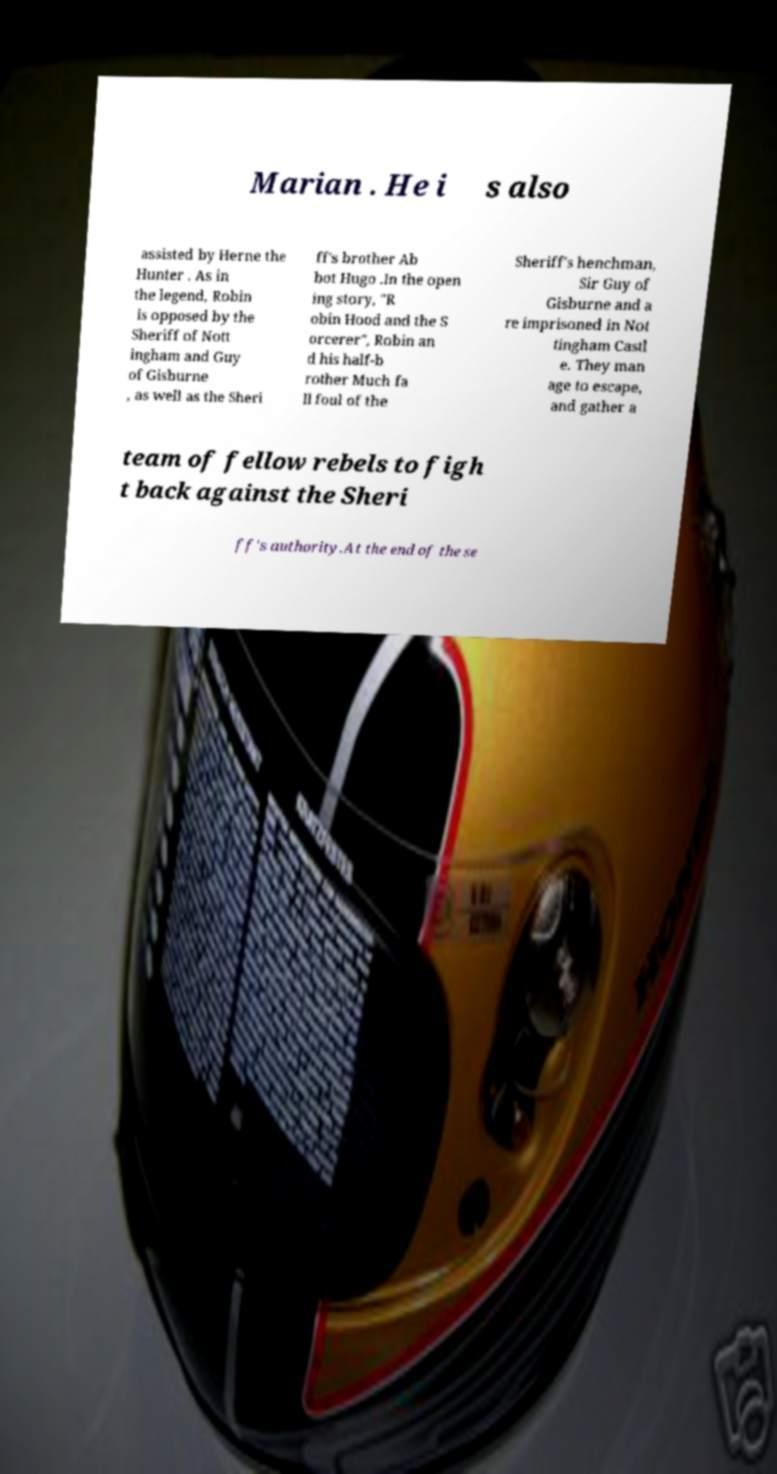Please identify and transcribe the text found in this image. Marian . He i s also assisted by Herne the Hunter . As in the legend, Robin is opposed by the Sheriff of Nott ingham and Guy of Gisburne , as well as the Sheri ff's brother Ab bot Hugo .In the open ing story, "R obin Hood and the S orcerer", Robin an d his half-b rother Much fa ll foul of the Sheriff's henchman, Sir Guy of Gisburne and a re imprisoned in Not tingham Castl e. They man age to escape, and gather a team of fellow rebels to figh t back against the Sheri ff's authority.At the end of the se 